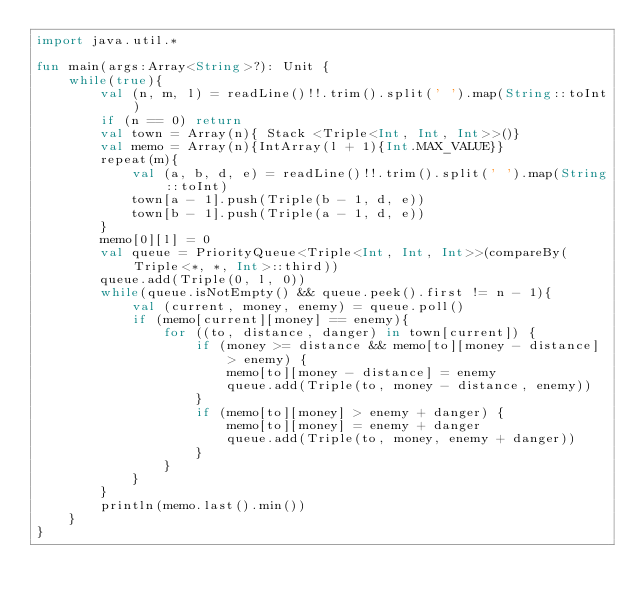Convert code to text. <code><loc_0><loc_0><loc_500><loc_500><_Kotlin_>import java.util.*

fun main(args:Array<String>?): Unit {
    while(true){
        val (n, m, l) = readLine()!!.trim().split(' ').map(String::toInt)
        if (n == 0) return
        val town = Array(n){ Stack <Triple<Int, Int, Int>>()}
        val memo = Array(n){IntArray(l + 1){Int.MAX_VALUE}}
        repeat(m){
            val (a, b, d, e) = readLine()!!.trim().split(' ').map(String::toInt)
            town[a - 1].push(Triple(b - 1, d, e))
            town[b - 1].push(Triple(a - 1, d, e))
        }
        memo[0][l] = 0
        val queue = PriorityQueue<Triple<Int, Int, Int>>(compareBy(Triple<*, *, Int>::third))
        queue.add(Triple(0, l, 0))
        while(queue.isNotEmpty() && queue.peek().first != n - 1){
            val (current, money, enemy) = queue.poll()
            if (memo[current][money] == enemy){
                for ((to, distance, danger) in town[current]) {
                    if (money >= distance && memo[to][money - distance] > enemy) {
                        memo[to][money - distance] = enemy
                        queue.add(Triple(to, money - distance, enemy))
                    }
                    if (memo[to][money] > enemy + danger) {
                        memo[to][money] = enemy + danger
                        queue.add(Triple(to, money, enemy + danger))
                    }
                }
            }
        }
        println(memo.last().min())
    }
}
</code> 